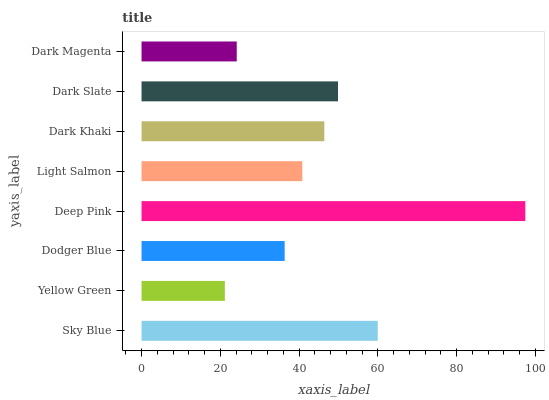Is Yellow Green the minimum?
Answer yes or no. Yes. Is Deep Pink the maximum?
Answer yes or no. Yes. Is Dodger Blue the minimum?
Answer yes or no. No. Is Dodger Blue the maximum?
Answer yes or no. No. Is Dodger Blue greater than Yellow Green?
Answer yes or no. Yes. Is Yellow Green less than Dodger Blue?
Answer yes or no. Yes. Is Yellow Green greater than Dodger Blue?
Answer yes or no. No. Is Dodger Blue less than Yellow Green?
Answer yes or no. No. Is Dark Khaki the high median?
Answer yes or no. Yes. Is Light Salmon the low median?
Answer yes or no. Yes. Is Dark Magenta the high median?
Answer yes or no. No. Is Sky Blue the low median?
Answer yes or no. No. 